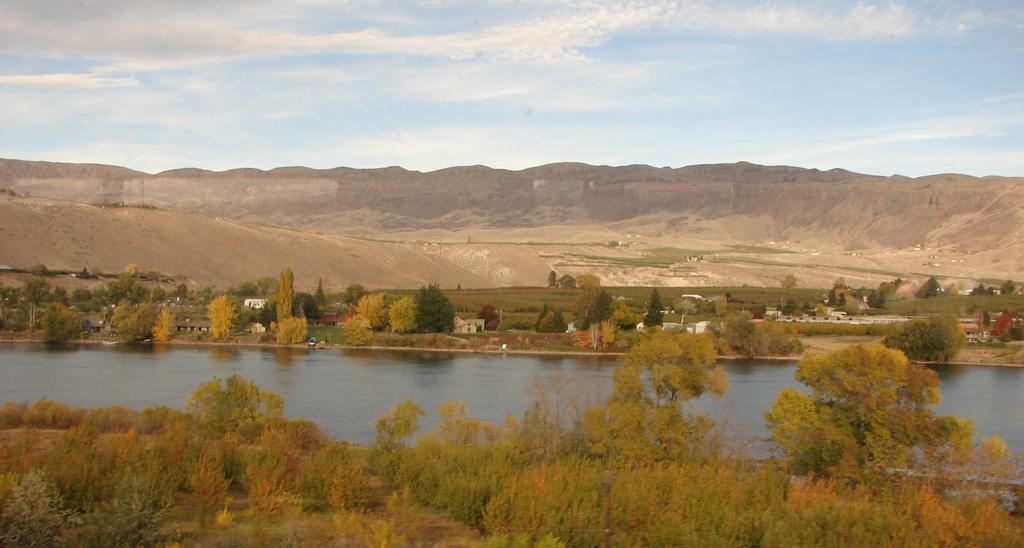In one or two sentences, can you explain what this image depicts? As we can see in the image there are trees, grass, water and houses. In the background there are hills. On the top there is sky. 